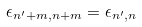Convert formula to latex. <formula><loc_0><loc_0><loc_500><loc_500>\epsilon _ { n ^ { \prime } + m , n + m } = \epsilon _ { n ^ { \prime } , n }</formula> 